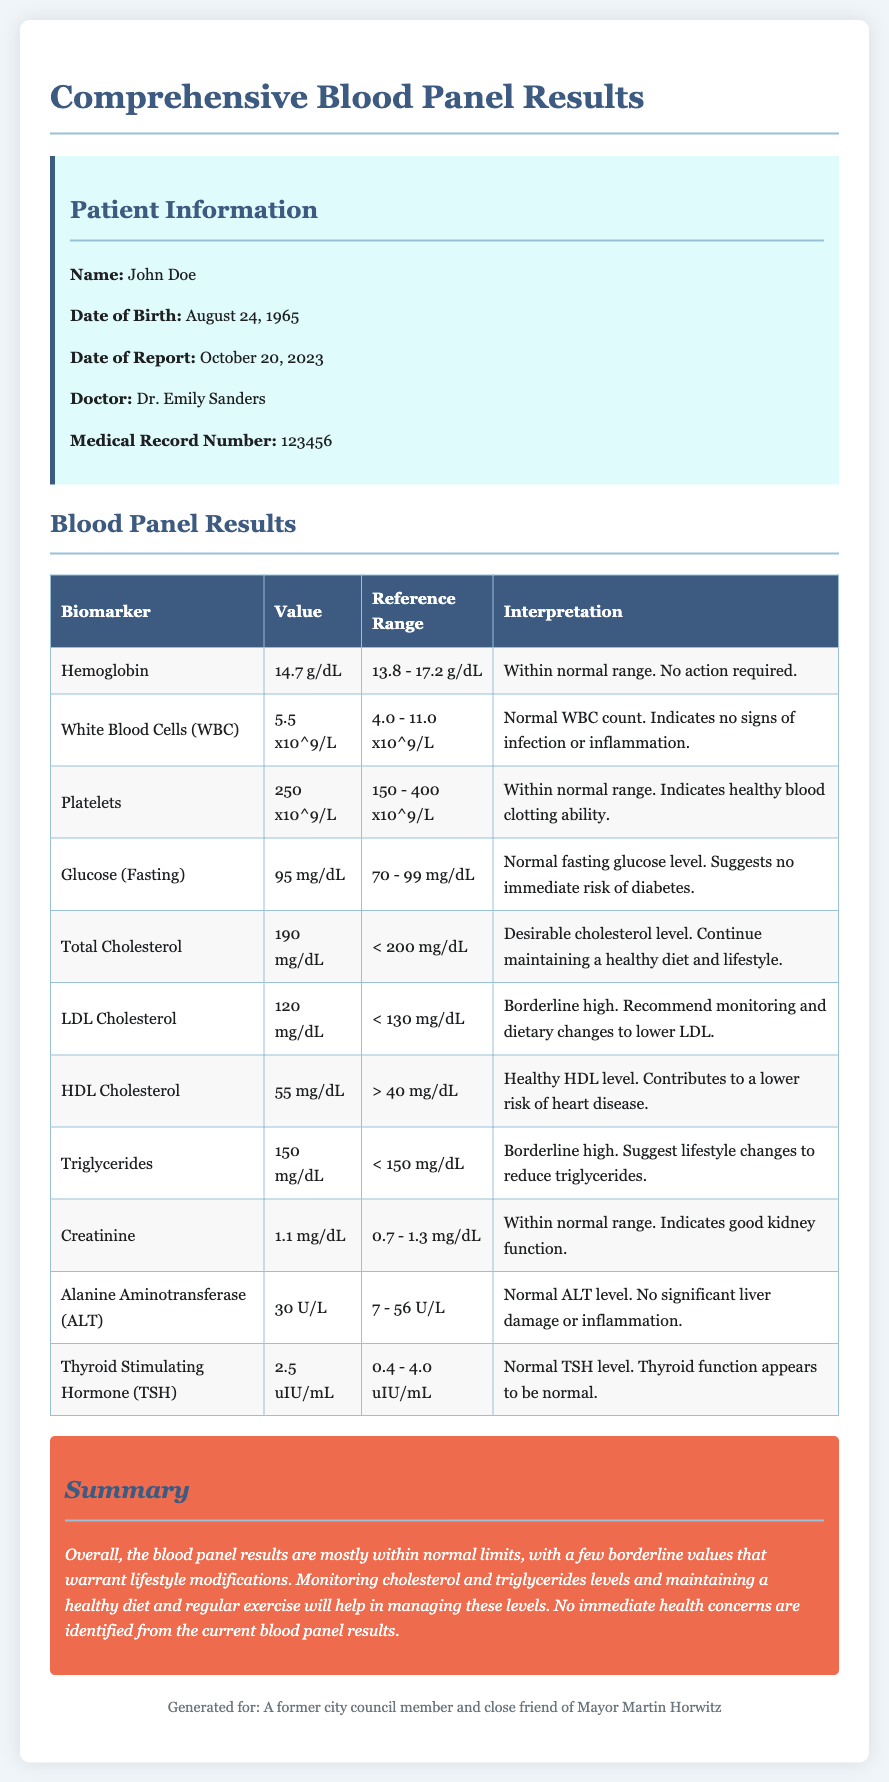What is the patient's name? The patient's name is mentioned in the Patient Information section of the document.
Answer: John Doe What is the date of report? The date of the report is noted in the Patient Information area, indicating when the results were generated.
Answer: October 20, 2023 What is the value of LDL Cholesterol? The value of LDL Cholesterol is found in the Blood Panel Results table under the respective biomarker.
Answer: 120 mg/dL What does a normal WBC count indicate? The interpretation for normal WBC count is provided in the corresponding row of the Blood Panel Results table.
Answer: Indicates no signs of infection or inflammation Is the glucose level within the normal range? This can be determined by looking at the Reference Range for Glucose (Fasting) in the Blood Panel Results table.
Answer: Yes What are the borderline high values in the results? This requires reviewing multiple biomarkers and their interpretations to determine which are flagged as borderline high.
Answer: LDL Cholesterol and Triglycerides How many biomarkers are listed in the blood panel results? The total comes from counting the number of rows in the Blood Panel Results table excluding the header.
Answer: 10 What does the summary say about the overall health? The summary provides insights into the implications of the results in one statement about overall health.
Answer: Overall, the blood panel results are mostly within normal limits Who is the doctor listed in the report? The doctor’s name is specifically noted in the Patient Information section.
Answer: Dr. Emily Sanders 